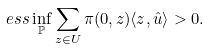Convert formula to latex. <formula><loc_0><loc_0><loc_500><loc_500>e s s \inf _ { \mathbb { P } } \sum _ { z \in U } \pi ( 0 , z ) \langle z , \hat { u } \rangle > 0 .</formula> 